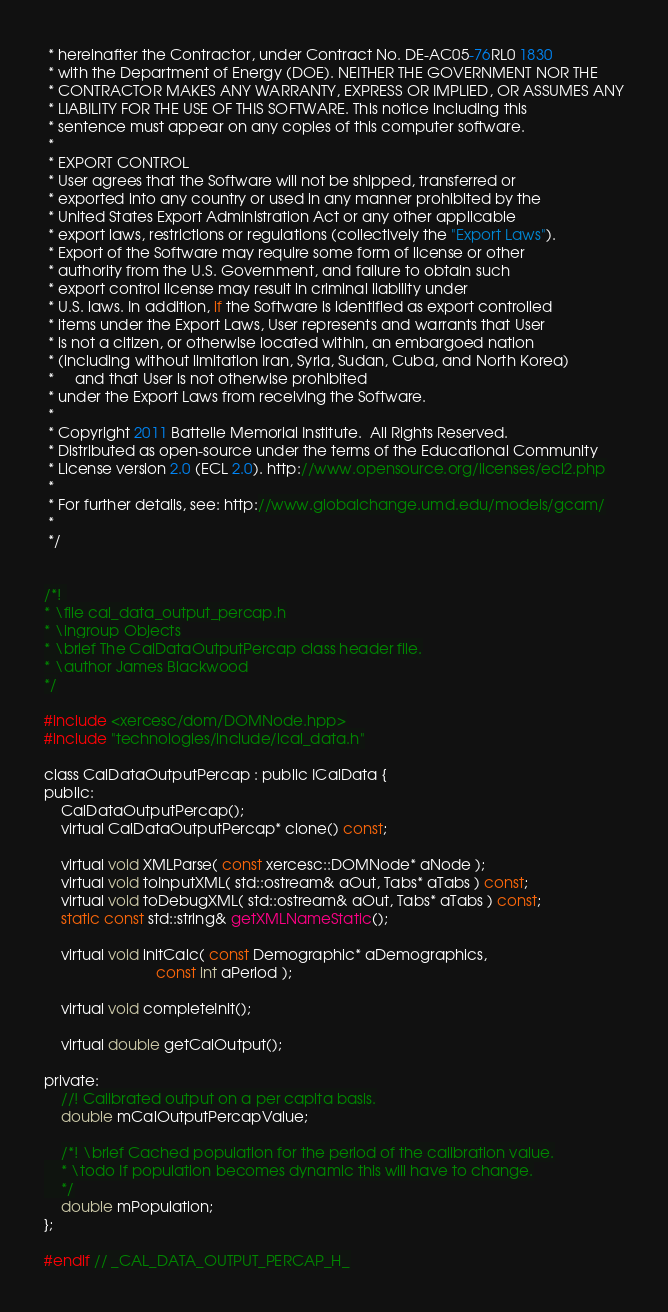<code> <loc_0><loc_0><loc_500><loc_500><_C_> * hereinafter the Contractor, under Contract No. DE-AC05-76RL0 1830
 * with the Department of Energy (DOE). NEITHER THE GOVERNMENT NOR THE
 * CONTRACTOR MAKES ANY WARRANTY, EXPRESS OR IMPLIED, OR ASSUMES ANY
 * LIABILITY FOR THE USE OF THIS SOFTWARE. This notice including this
 * sentence must appear on any copies of this computer software.
 * 
 * EXPORT CONTROL
 * User agrees that the Software will not be shipped, transferred or
 * exported into any country or used in any manner prohibited by the
 * United States Export Administration Act or any other applicable
 * export laws, restrictions or regulations (collectively the "Export Laws").
 * Export of the Software may require some form of license or other
 * authority from the U.S. Government, and failure to obtain such
 * export control license may result in criminal liability under
 * U.S. laws. In addition, if the Software is identified as export controlled
 * items under the Export Laws, User represents and warrants that User
 * is not a citizen, or otherwise located within, an embargoed nation
 * (including without limitation Iran, Syria, Sudan, Cuba, and North Korea)
 *     and that User is not otherwise prohibited
 * under the Export Laws from receiving the Software.
 * 
 * Copyright 2011 Battelle Memorial Institute.  All Rights Reserved.
 * Distributed as open-source under the terms of the Educational Community 
 * License version 2.0 (ECL 2.0). http://www.opensource.org/licenses/ecl2.php
 * 
 * For further details, see: http://www.globalchange.umd.edu/models/gcam/
 * 
 */


/*! 
* \file cal_data_output_percap.h
* \ingroup Objects
* \brief The CalDataOutputPercap class header file.
* \author James Blackwood
*/

#include <xercesc/dom/DOMNode.hpp>
#include "technologies/include/ical_data.h"

class CalDataOutputPercap : public ICalData {
public:
    CalDataOutputPercap();
    virtual CalDataOutputPercap* clone() const;

    virtual void XMLParse( const xercesc::DOMNode* aNode );
    virtual void toInputXML( std::ostream& aOut, Tabs* aTabs ) const;
    virtual void toDebugXML( std::ostream& aOut, Tabs* aTabs ) const;
    static const std::string& getXMLNameStatic();

    virtual void initCalc( const Demographic* aDemographics,
                           const int aPeriod );
    
    virtual void completeInit();

    virtual double getCalOutput();

private:
    //! Calibrated output on a per capita basis.
    double mCalOutputPercapValue;

    /*! \brief Cached population for the period of the calibration value.
    * \todo If population becomes dynamic this will have to change.
    */
    double mPopulation;
};

#endif // _CAL_DATA_OUTPUT_PERCAP_H_
</code> 